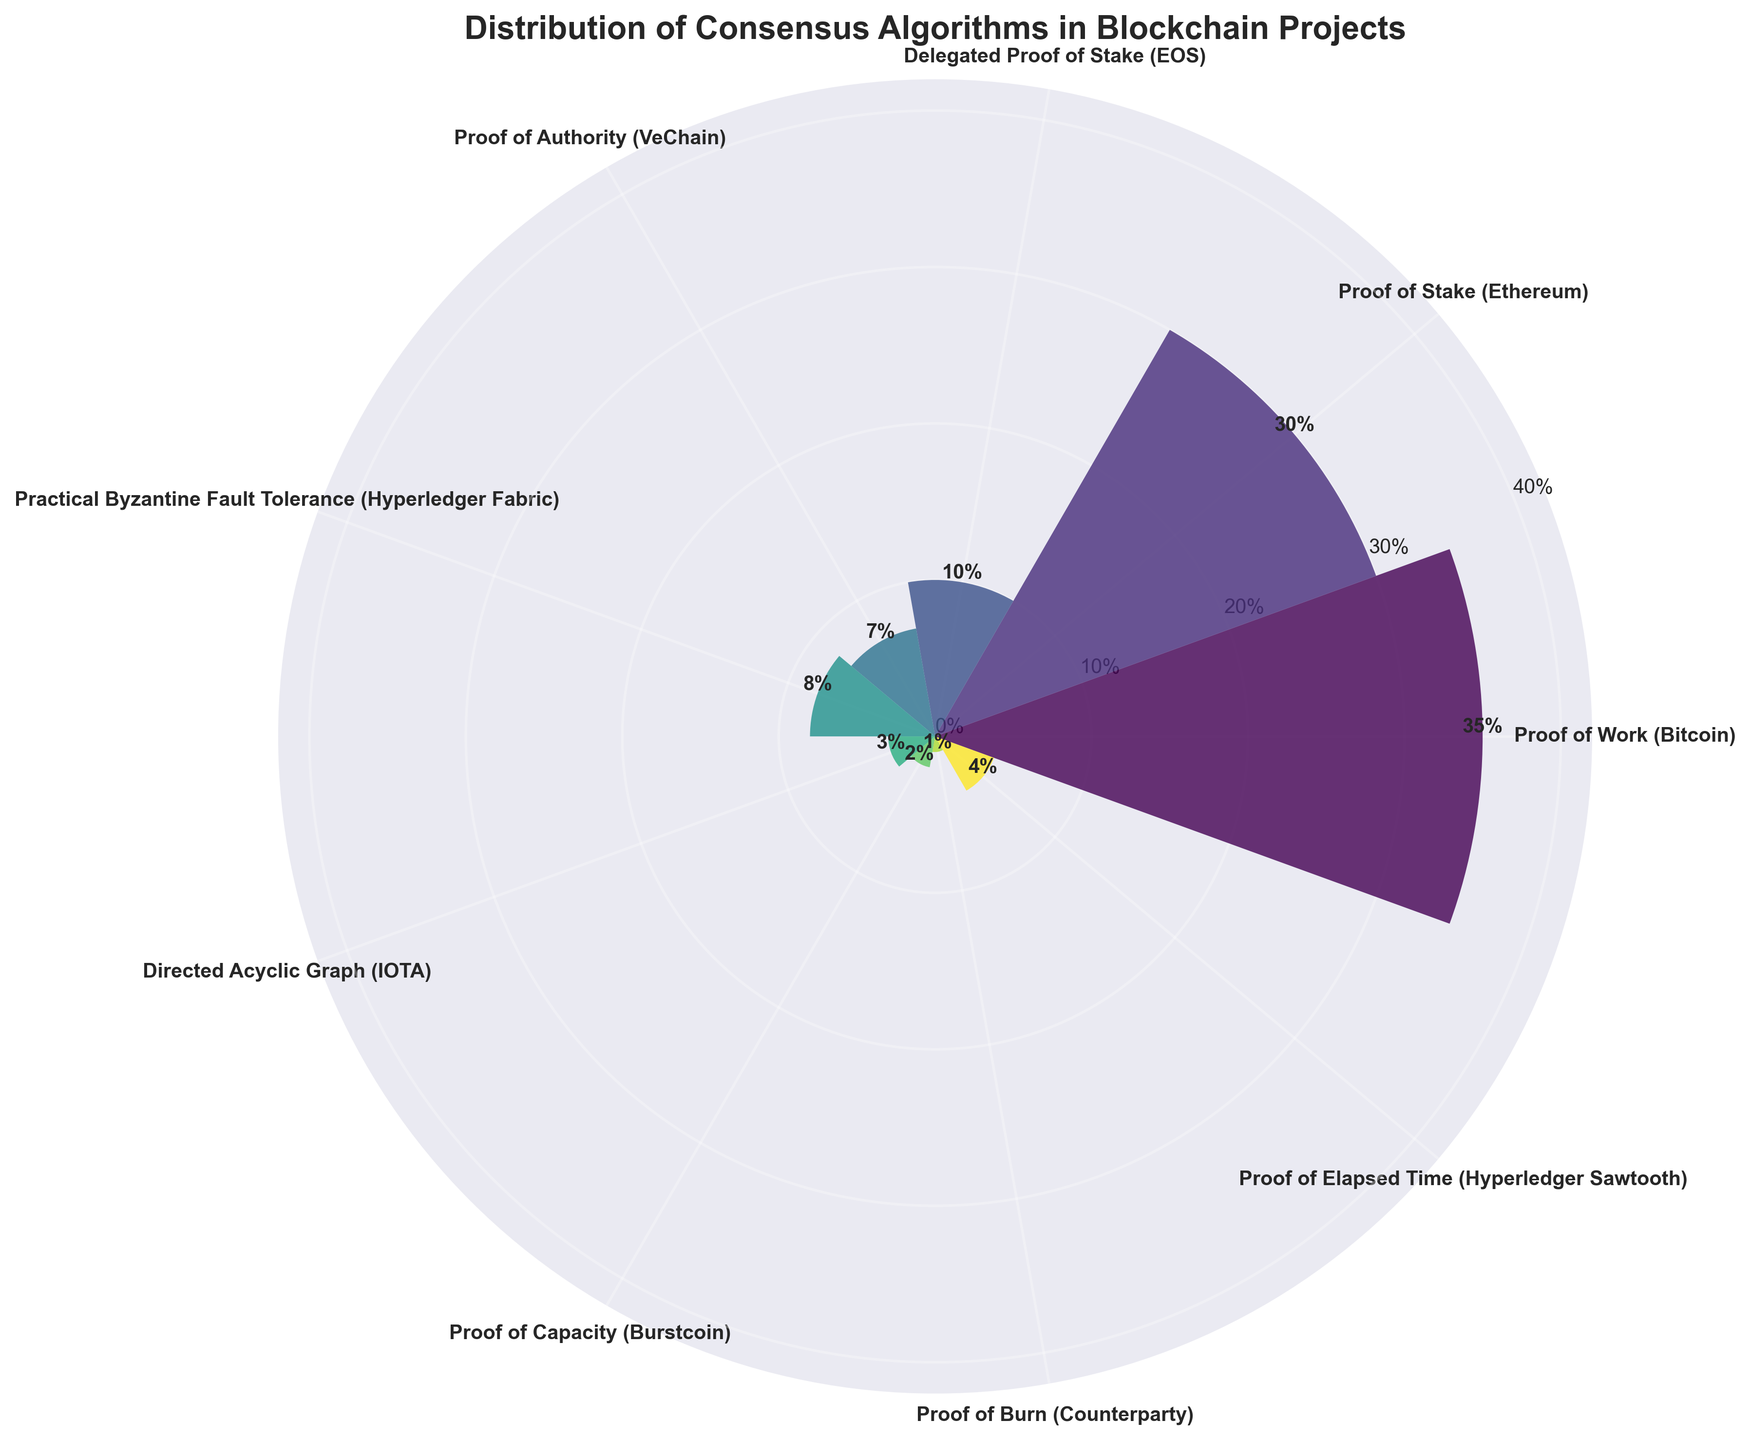What is the title of the figure? The title is displayed at the top of the figure. It reads 'Distribution of Consensus Algorithms in Blockchain Projects'.
Answer: Distribution of Consensus Algorithms in Blockchain Projects Which consensus algorithm has the largest market share? By looking at the bars in the chart, the longest bar represents the algorithm with the largest market share. The longest bar corresponds to 'Proof of Work (Bitcoin)' with a market share of 35%.
Answer: Proof of Work (Bitcoin) What is the total market share of Proof of Stake and Delegated Proof of Stake combined? The market share of 'Proof of Stake (Ethereum)' is 30% and 'Delegated Proof of Stake (EOS)' is 10%. Adding these two values together gives the total market share.
Answer: 40% How many consensus algorithms are shown in the chart? Count the number of data points or bars displayed in the chart. Each bar corresponds to one consensus algorithm. There are 9 bars in the chart.
Answer: 9 Which consensus algorithm has the smallest market share? By observing the length of the bars, the shortest bar represents the algorithm with the smallest market share. 'Proof of Burn (Counterparty)' has the smallest market share with 1%.
Answer: Proof of Burn (Counterparty) How does the market share of Proof of Authority compare to Directed Acyclic Graph? 'Proof of Authority (VeChain)' has a market share of 7% while 'Directed Acyclic Graph (IOTA)' has a market share of 3%. 'Proof of Authority' has a greater market share compared to 'Directed Acyclic Graph'.
Answer: Greater What is the average market share of all the depicted consensus algorithms? Sum all the market shares (35% + 30% + 10% + 7% + 8% + 3% + 2% + 1% + 4%) = 100%. There are 9 algorithms, so the average is 100%/9.
Answer: 11.11% Which three consensus algorithms have market shares that sum up to roughly half of the total market share? The total market share is 100%. To find three algorithms with a combined market share close to 50%, observe the bars and their values. 'Proof of Work (Bitcoin)' (35%), 'Proof of Stake (Ethereum)' (30%), and 'Proof of Authority (VeChain)' (7%) sum up to 72%, which is the combination that sums closest to 50%.
Answer: Proof of Work, Proof of Stake, Proof of Authority What is the difference in market share between Proof of Work and Proof of Elapsed Time? 'Proof of Work (Bitcoin)' has a market share of 35% and 'Proof of Elapsed Time (Hyperledger Sawtooth)' has 4%. The difference is calculated as 35% - 4%.
Answer: 31% What consensus algorithms have more than 5% market share? Observe the bars with labels showing market share percentages. Those with more than 5% are 'Proof of Work (Bitcoin)' (35%), 'Proof of Stake (Ethereum)' (30%), 'Delegated Proof of Stake (EOS)' (10%), 'Practical Byzantine Fault Tolerance (Hyperledger Fabric)' (8%), and 'Proof of Authority (VeChain)' (7%).
Answer: Proof of Work, Proof of Stake, Delegated Proof of Stake, Practical Byzantine Fault Tolerance, Proof of Authority 